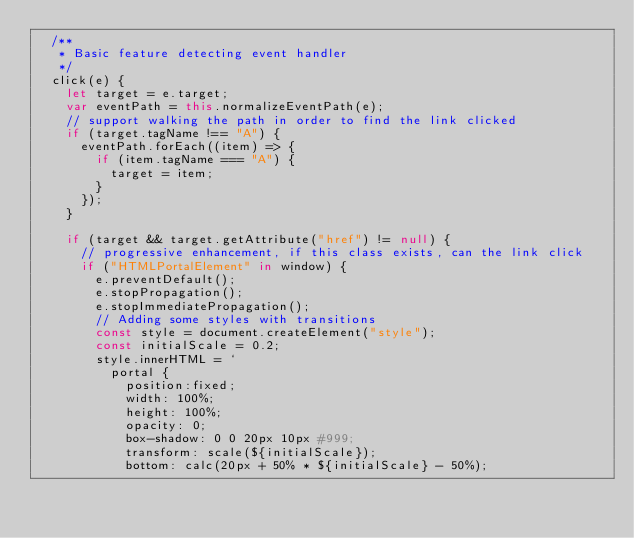Convert code to text. <code><loc_0><loc_0><loc_500><loc_500><_JavaScript_>  /**
   * Basic feature detecting event handler
   */
  click(e) {
    let target = e.target;
    var eventPath = this.normalizeEventPath(e);
    // support walking the path in order to find the link clicked
    if (target.tagName !== "A") {
      eventPath.forEach((item) => {
        if (item.tagName === "A") {
          target = item;
        }
      });
    }

    if (target && target.getAttribute("href") != null) {
      // progressive enhancement, if this class exists, can the link click
      if ("HTMLPortalElement" in window) {
        e.preventDefault();
        e.stopPropagation();
        e.stopImmediatePropagation();
        // Adding some styles with transitions
        const style = document.createElement("style");
        const initialScale = 0.2;
        style.innerHTML = `
          portal {
            position:fixed;
            width: 100%;
            height: 100%;
            opacity: 0;
            box-shadow: 0 0 20px 10px #999;
            transform: scale(${initialScale});
            bottom: calc(20px + 50% * ${initialScale} - 50%);</code> 